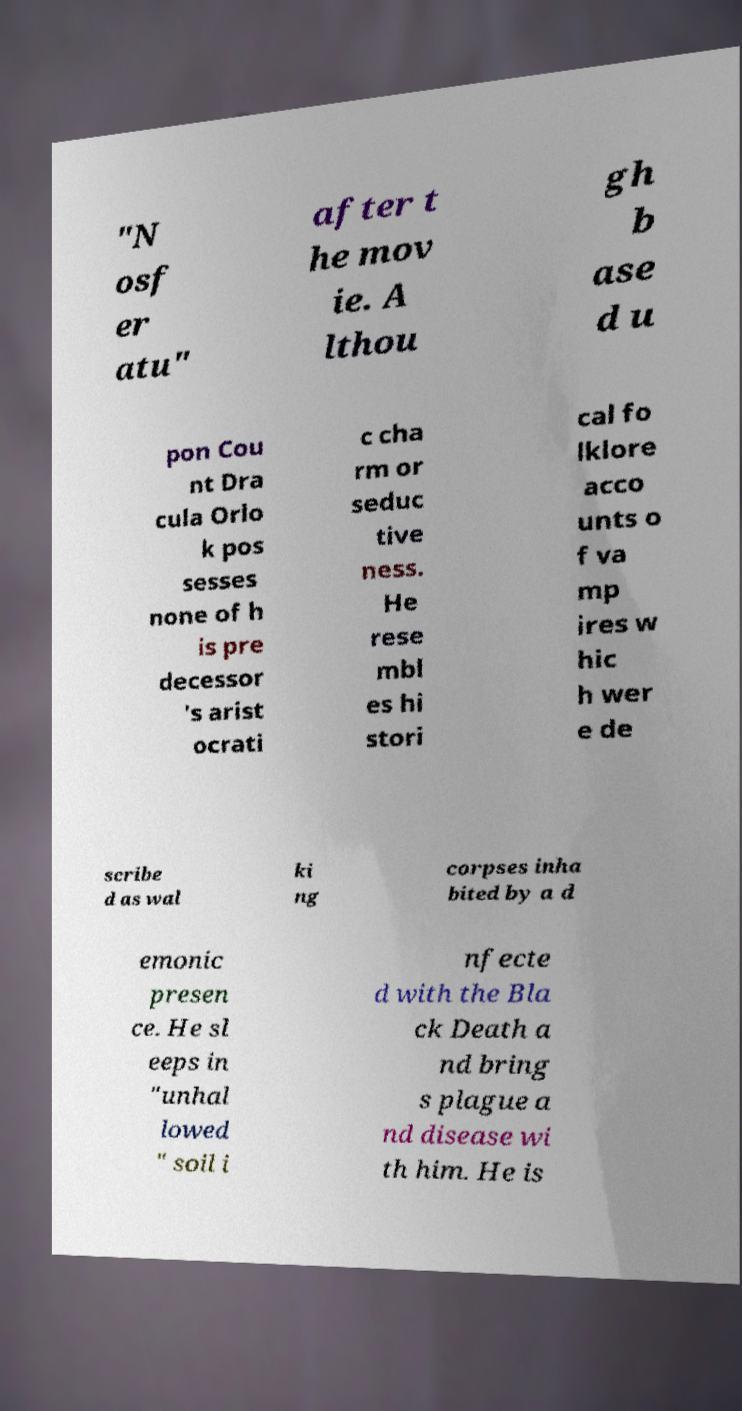Please identify and transcribe the text found in this image. "N osf er atu" after t he mov ie. A lthou gh b ase d u pon Cou nt Dra cula Orlo k pos sesses none of h is pre decessor 's arist ocrati c cha rm or seduc tive ness. He rese mbl es hi stori cal fo lklore acco unts o f va mp ires w hic h wer e de scribe d as wal ki ng corpses inha bited by a d emonic presen ce. He sl eeps in "unhal lowed " soil i nfecte d with the Bla ck Death a nd bring s plague a nd disease wi th him. He is 